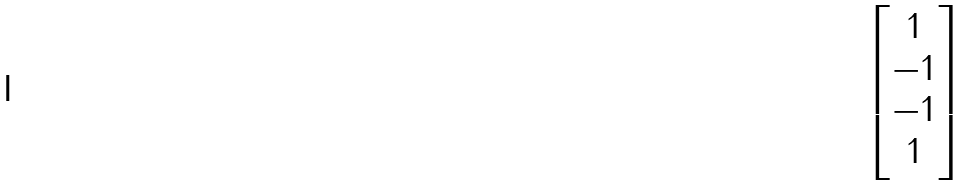<formula> <loc_0><loc_0><loc_500><loc_500>\begin{bmatrix} 1 \\ - 1 \\ - 1 \\ 1 \end{bmatrix}</formula> 